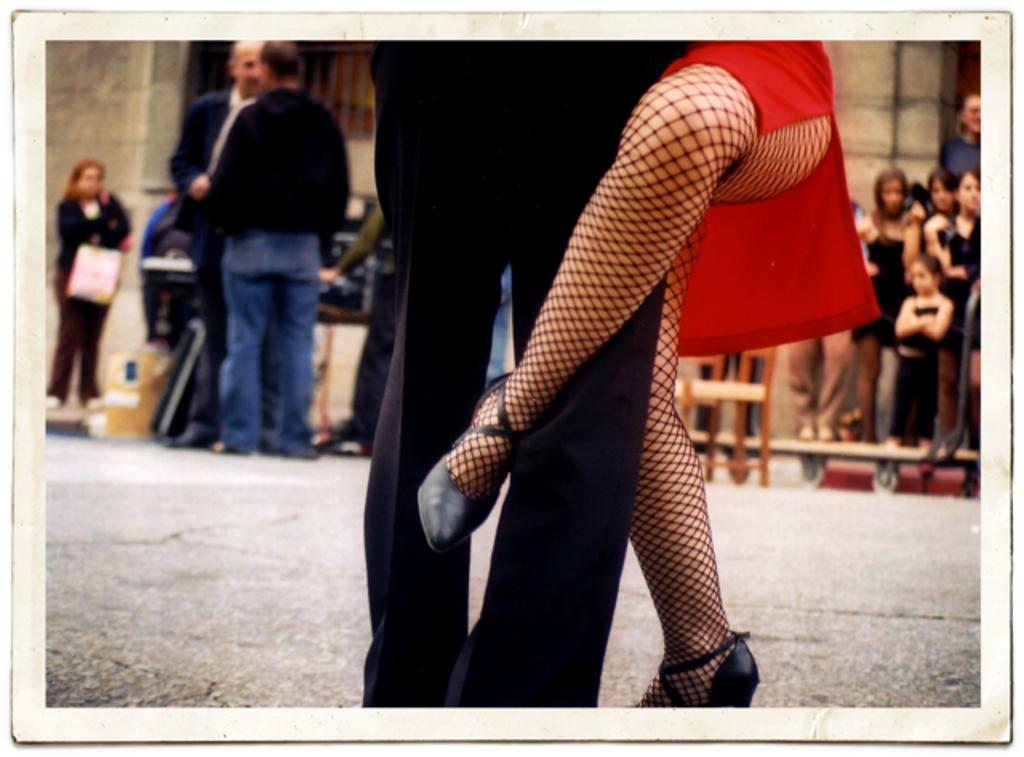How many people are present in the image? There are two pairs of legs visible in the image, suggesting that there are two people present. What can be inferred about the people in the image? The people in the image are wearing clothes. What is the background of the image? The people are standing in front of a wall. What type of plough is being used by the people in the image? There is no plough present in the image; it features two people standing in front of a wall. How does the light affect the image? The provided facts do not mention any light source or lighting conditions in the image. 